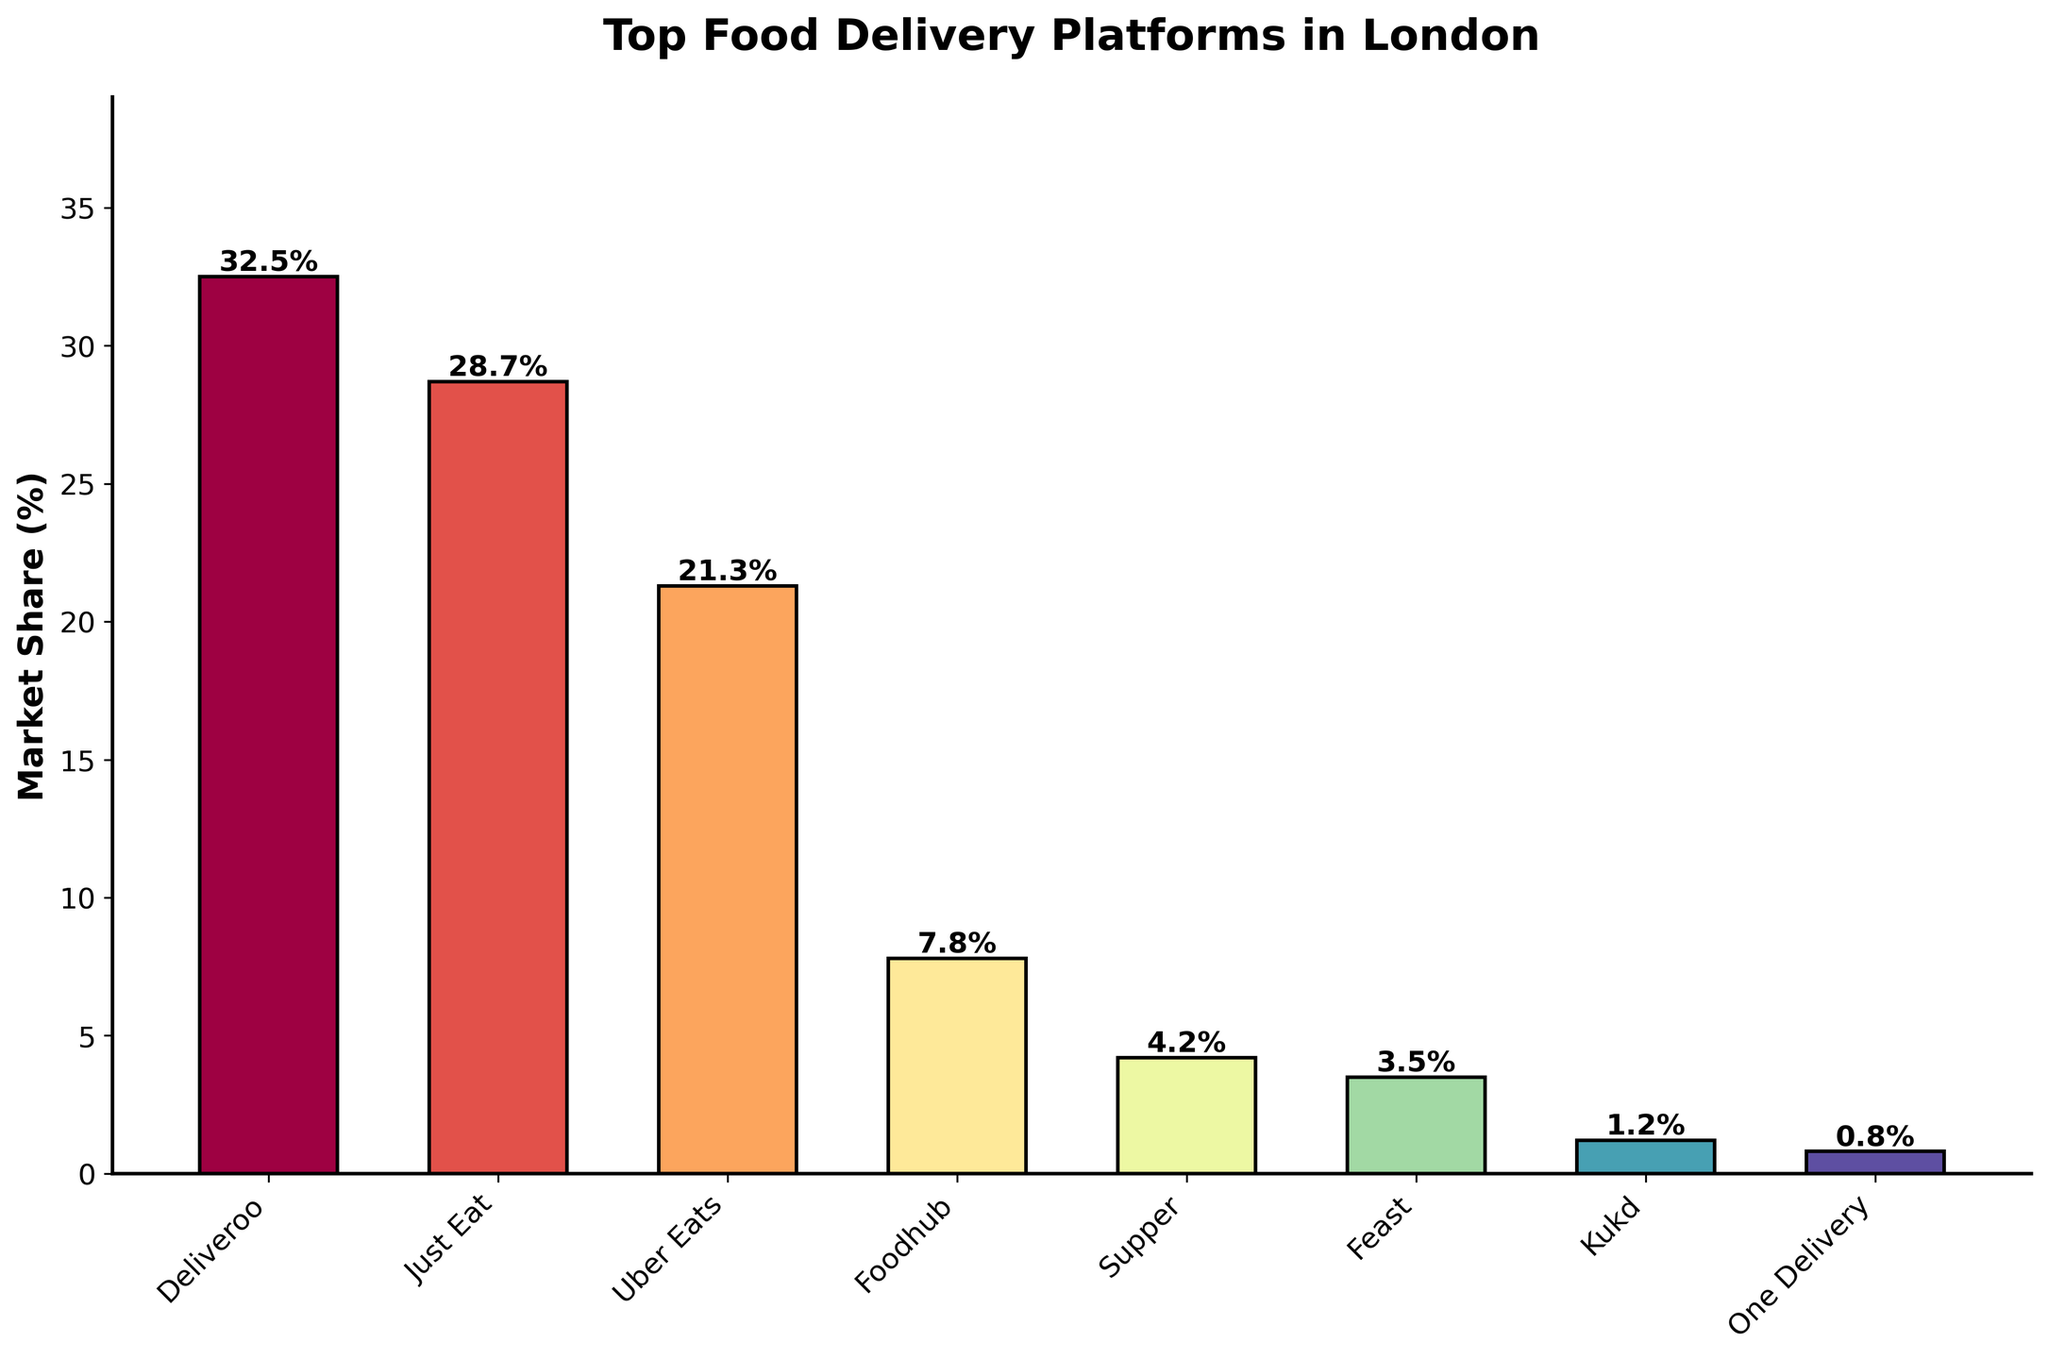What's the platform with the highest market share? The platform with the highest market share can be identified by looking for the tallest bar. In this case, Deliveroo has the tallest bar, indicating it has the highest market share of 32.5%.
Answer: Deliveroo Which platform has the smallest market share? The platform with the smallest market share can be identified by looking for the shortest bar. In this case, One Delivery has the shortest bar, indicating it has the smallest market share of 0.8%.
Answer: One Delivery What's the total market share of Just Eat and Uber Eats combined? To find the combined market share of Just Eat and Uber Eats, sum their individual shares: 28.7% (Just Eat) + 21.3% (Uber Eats) = 50.0%.
Answer: 50.0% How much larger is Deliveroo's market share compared to Foodhub's? Subtract Foodhub's market share from Deliveroo's market share: 32.5% (Deliveroo) - 7.8% (Foodhub) = 24.7%.
Answer: 24.7% What is the average market share of all platforms? Sum the market shares of all platforms and then divide by the number of platforms: 
(32.5% + 28.7% + 21.3% + 7.8% + 4.2% + 3.5% + 1.2% + 0.8%) / 8 = 100.0% / 8 = 12.5%.
Answer: 12.5% How does Foodhub's market share compare to Supper's? Compare the values directly. Foodhub has a market share of 7.8%, while Supper has a market share of 4.2%. Therefore, Foodhub's market share is higher.
Answer: Higher What's the cumulative market share of platforms with less than 5% market share individually? Identify the platforms with market share below 5% and sum their values: 4.2% (Supper) + 3.5% (Feast) + 1.2% (Kukd) + 0.8% (One Delivery) = 9.7%.
Answer: 9.7% Which platform has the third largest market share? By inspecting the bar heights and values, Uber Eats has the third highest market share of 21.3%, after Deliveroo and Just Eat.
Answer: Uber Eats Is the market share of Deliveroo more than the combined market share of Foodhub, Supper, and Feast? Sum the market shares of Foodhub, Supper, and Feast: 7.8% + 4.2% + 3.5% = 15.5%. Since Deliveroo's market share is 32.5%, it is indeed higher.
Answer: Yes What is the difference in market share between the top and bottom platforms? Subtract the market share of One Delivery (bottom) from Deliveroo (top): 32.5% - 0.8% = 31.7%.
Answer: 31.7% 